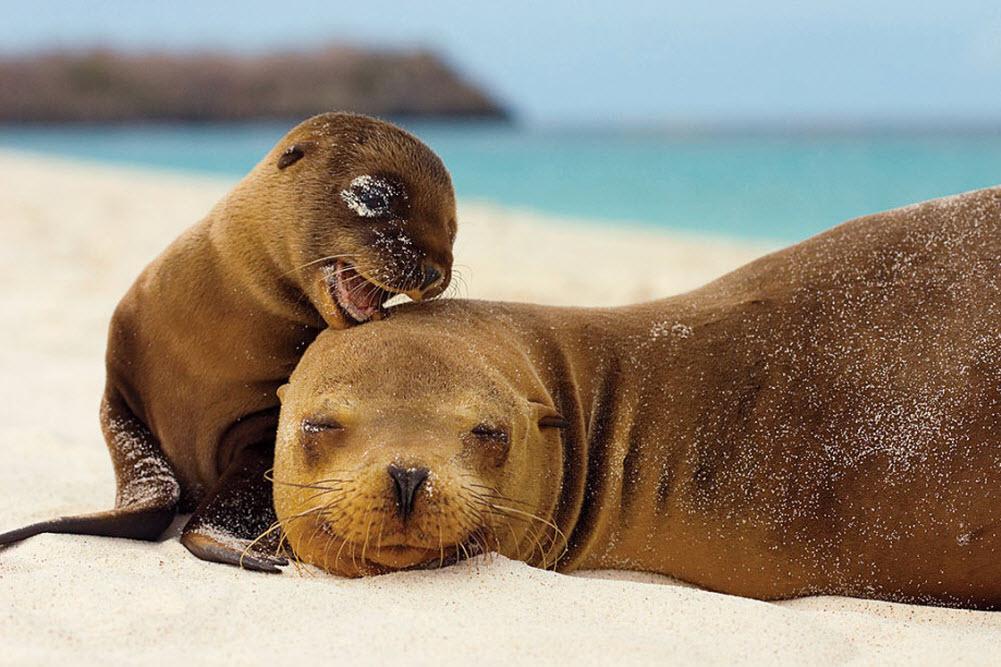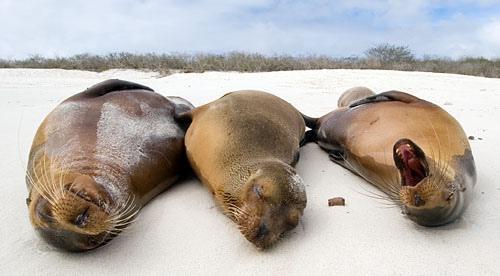The first image is the image on the left, the second image is the image on the right. Given the left and right images, does the statement "There are 5 sea lions in total." hold true? Answer yes or no. Yes. 